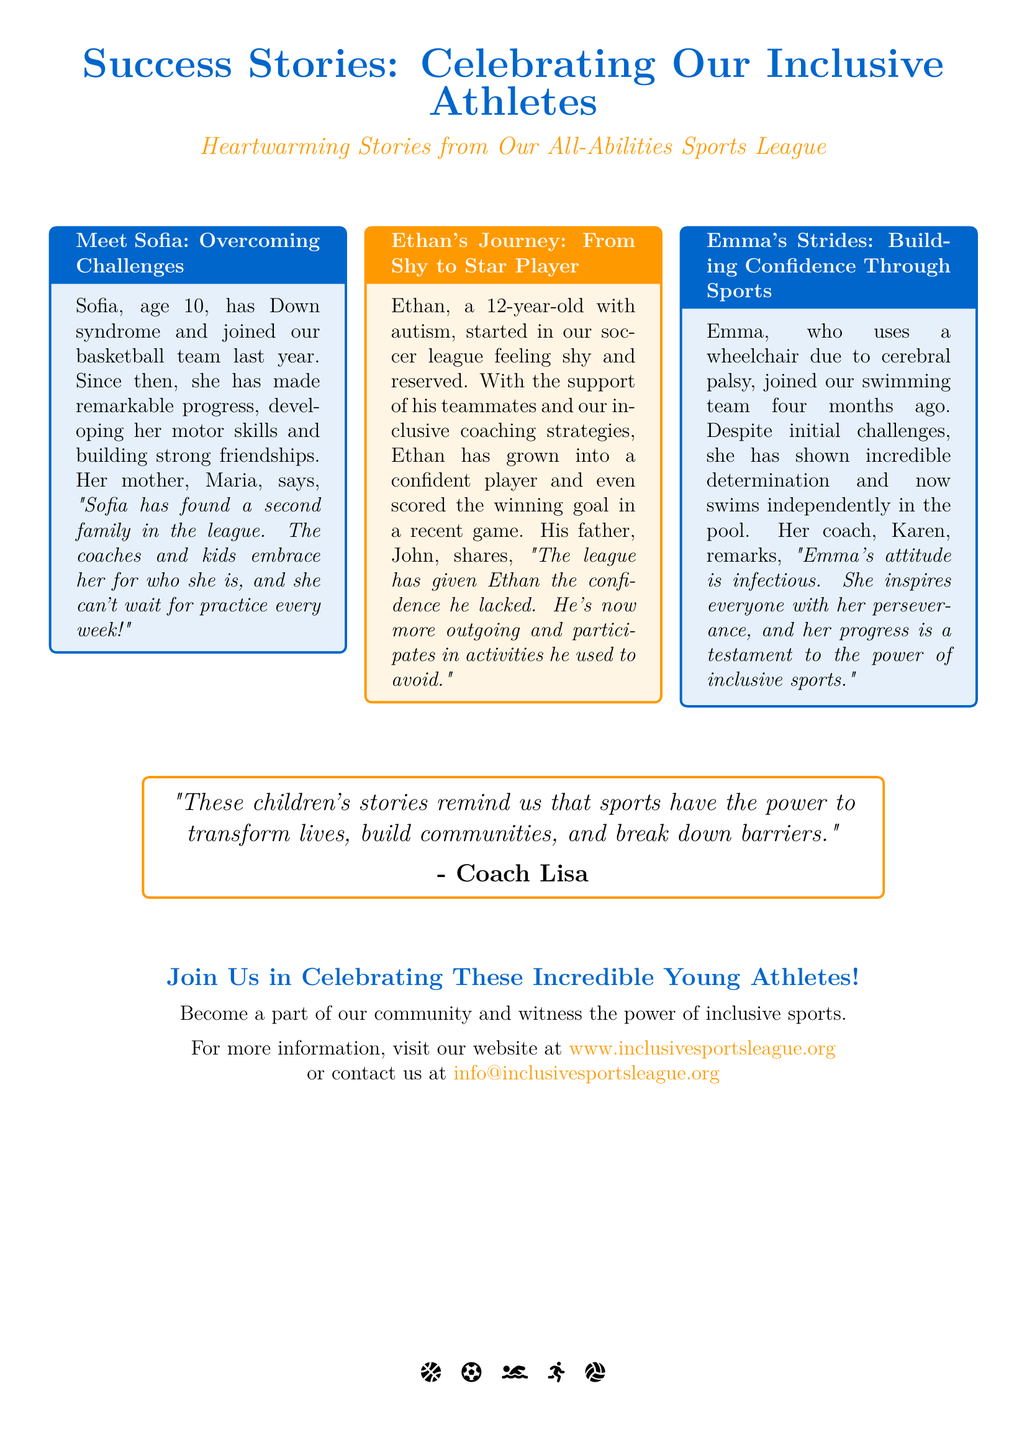What is the title of the flyer? The title is prominently stated at the top of the flyer.
Answer: Success Stories: Celebrating Our Inclusive Athletes How old is Sofia? The flyer provides the age of Sofia in her story section.
Answer: 10 What sport does Emma participate in? The document specifies the sport Emma is involved in.
Answer: Swimming Who is Ethan's father? The document mentions Ethan's father's name in his success story.
Answer: John What did Sofia's mother say about the league? The quote from Sofia's mother is included in her story.
Answer: "Sofia has found a second family in the league." How many stories are featured in the document? The flyer lists the number of individual stories included.
Answer: Three What is Coach Lisa's perspective on the power of sports? Coach Lisa shares a quote in the center box of the flyer.
Answer: "These children's stories remind us that sports have the power to transform lives, build communities, and break down barriers." What is the website for more information? The flyer provides a contact website for additional details.
Answer: www.inclusivesportsleague.org What has Ethan achieved in soccer? The document mentions a specific accomplishment of Ethan in his section.
Answer: Scored the winning goal What color is used for the title text? The primary color used for the title text is specified in the flyer.
Answer: RGB(0,102,204) 